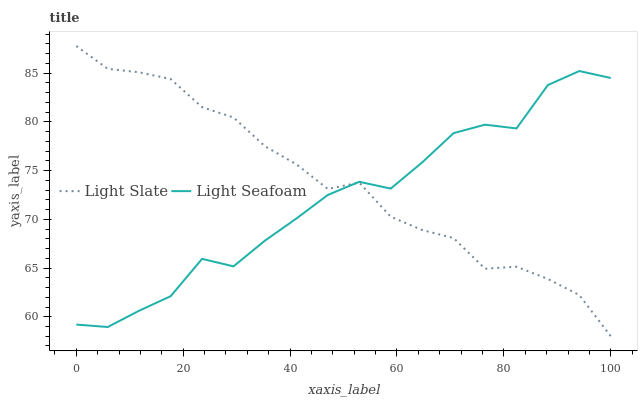Does Light Seafoam have the minimum area under the curve?
Answer yes or no. Yes. Does Light Slate have the maximum area under the curve?
Answer yes or no. Yes. Does Light Seafoam have the maximum area under the curve?
Answer yes or no. No. Is Light Slate the smoothest?
Answer yes or no. Yes. Is Light Seafoam the roughest?
Answer yes or no. Yes. Is Light Seafoam the smoothest?
Answer yes or no. No. Does Light Slate have the lowest value?
Answer yes or no. Yes. Does Light Seafoam have the lowest value?
Answer yes or no. No. Does Light Slate have the highest value?
Answer yes or no. Yes. Does Light Seafoam have the highest value?
Answer yes or no. No. Does Light Seafoam intersect Light Slate?
Answer yes or no. Yes. Is Light Seafoam less than Light Slate?
Answer yes or no. No. Is Light Seafoam greater than Light Slate?
Answer yes or no. No. 